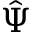Convert formula to latex. <formula><loc_0><loc_0><loc_500><loc_500>\hat { \Psi }</formula> 